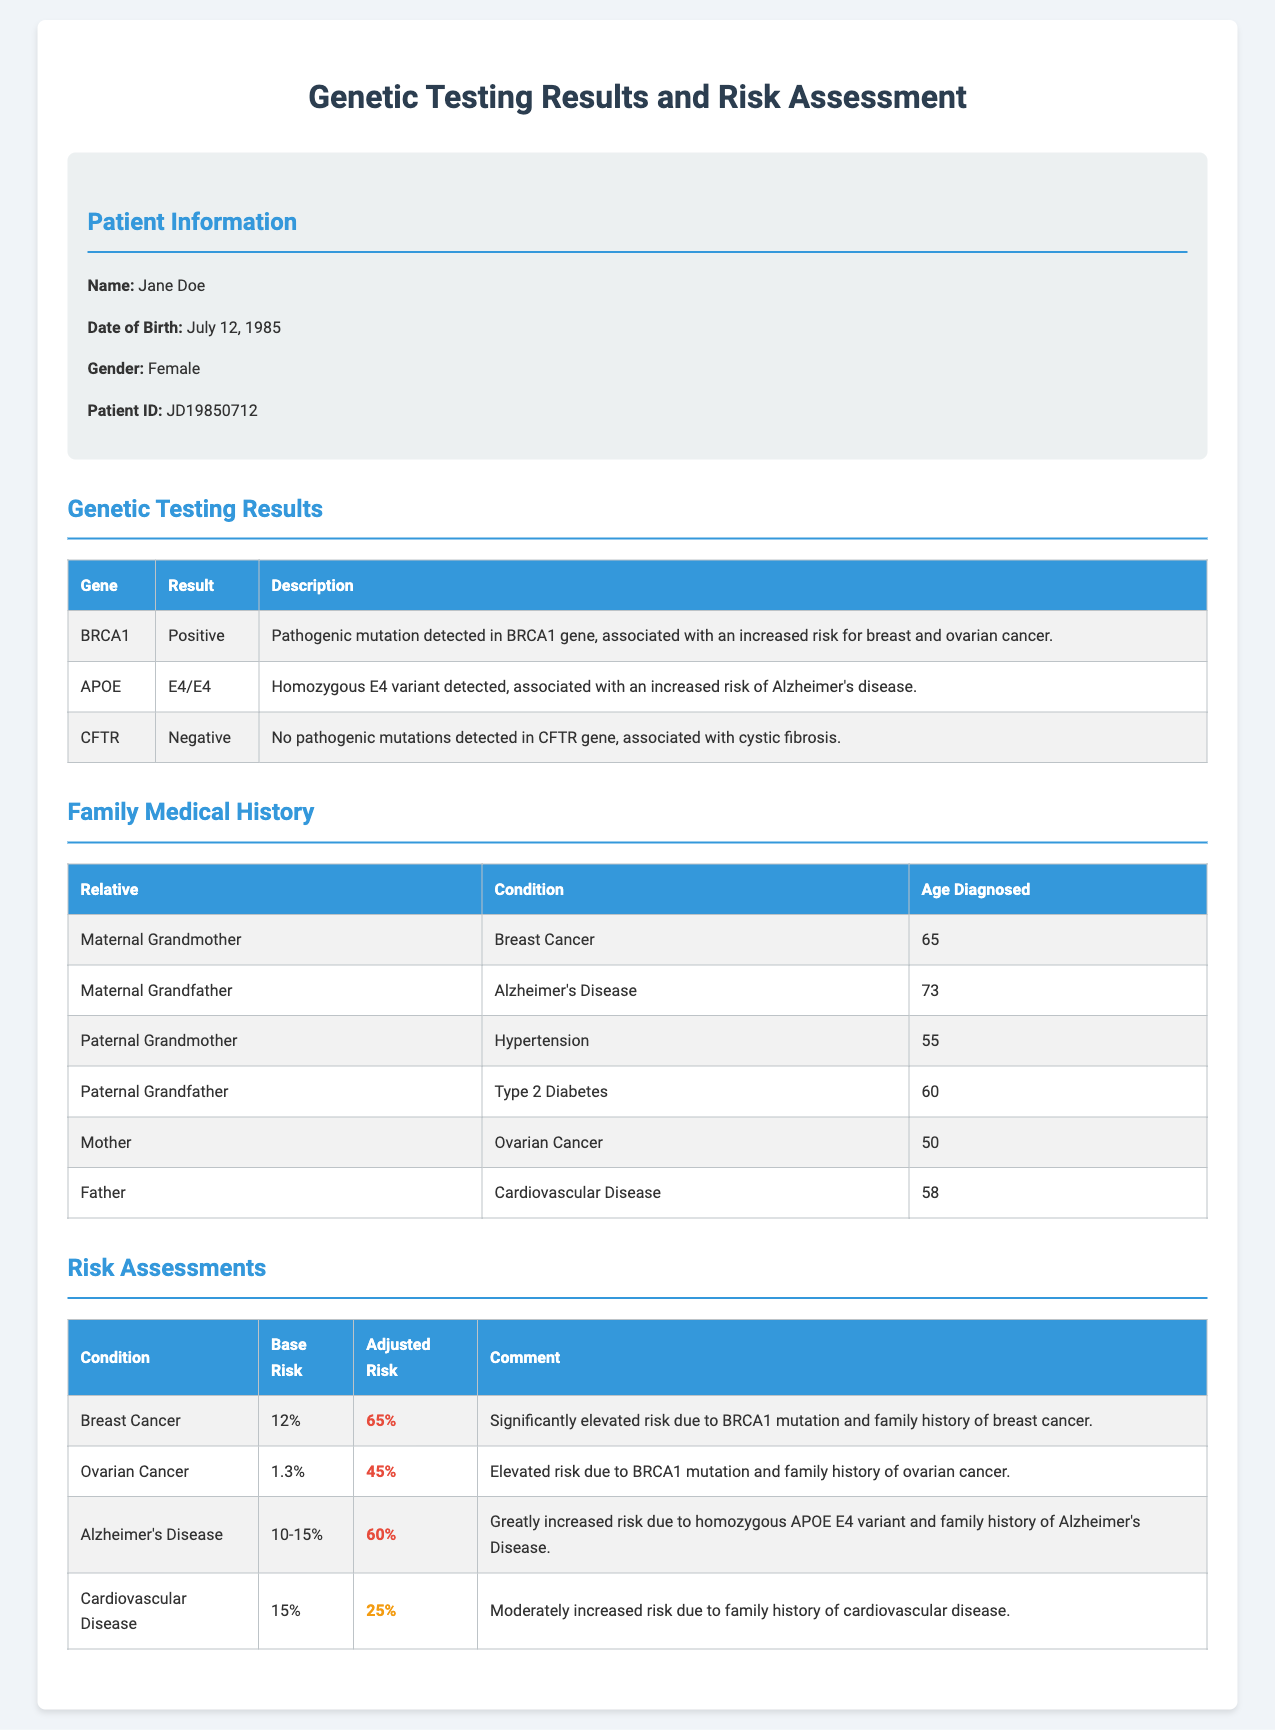What is the patient's name? The patient's name is provided in the Patient Information section of the document.
Answer: Jane Doe What is the date of birth of the patient? The date of birth is also found in the Patient Information section.
Answer: July 12, 1985 How many high-risk conditions are listed in the risk assessment? The number of high-risk conditions can be counted from the table in the risk assessment section.
Answer: 3 What mutation was detected in the BRCA1 gene? The specific information regarding the mutation in the BRCA1 gene is found in the Genetic Testing Results section.
Answer: Pathogenic mutation What is the adjusted risk percentage for Ovarian Cancer? The adjusted risk percentage is provided in the risk assessment table for Ovarian Cancer.
Answer: 45% Which family member had Alzheimer's Disease? The family member with Alzheimer's Disease is listed in the Family Medical History section.
Answer: Maternal Grandfather What is the base risk percentage for Breast Cancer? The base risk percentage can be found in the risk assessment table for Breast Cancer.
Answer: 12% What is the patient's risk level for Cardiovascular Disease? The risk level is indicated in the risk assessment table for Cardiovascular Disease.
Answer: Moderate risk 